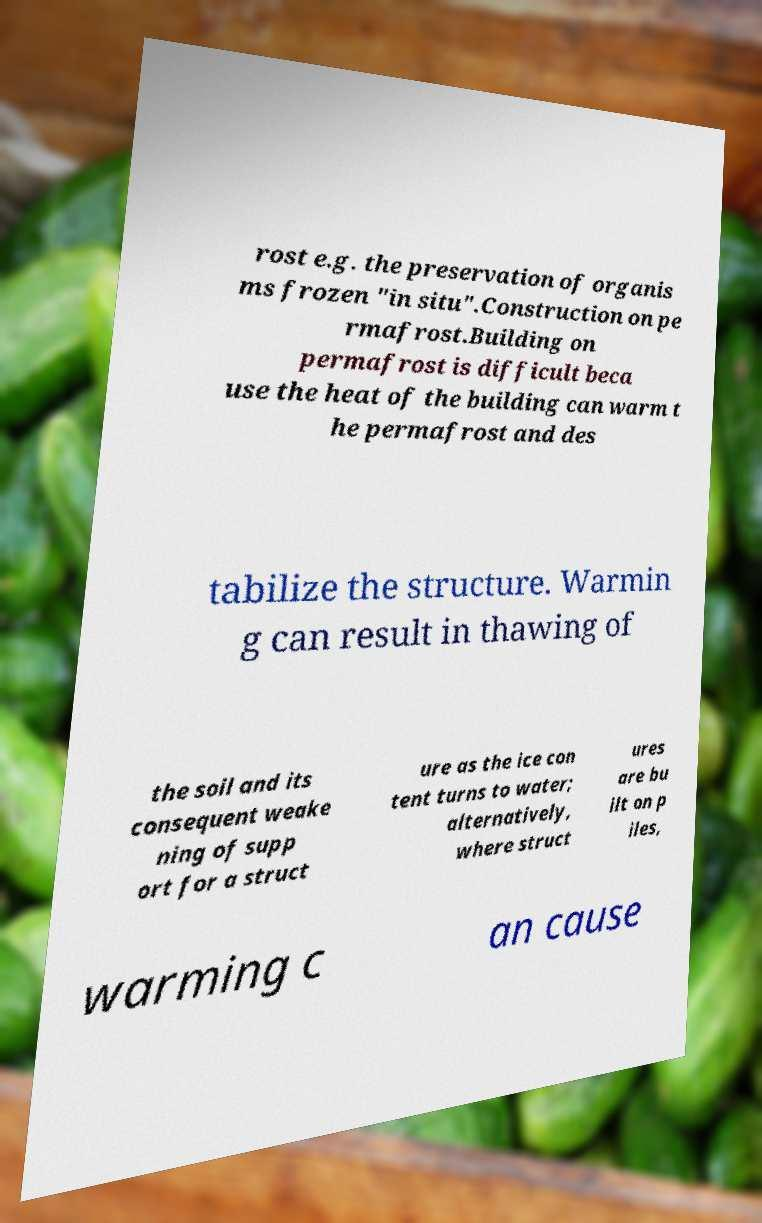Can you accurately transcribe the text from the provided image for me? rost e.g. the preservation of organis ms frozen "in situ".Construction on pe rmafrost.Building on permafrost is difficult beca use the heat of the building can warm t he permafrost and des tabilize the structure. Warmin g can result in thawing of the soil and its consequent weake ning of supp ort for a struct ure as the ice con tent turns to water; alternatively, where struct ures are bu ilt on p iles, warming c an cause 